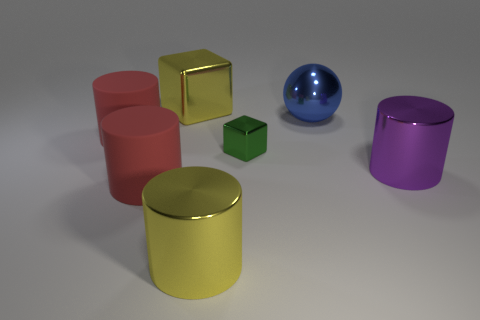There is a shiny cylinder that is left of the big purple cylinder that is in front of the big blue thing; what color is it?
Give a very brief answer. Yellow. There is a object that is to the right of the big blue metallic thing; is it the same shape as the red matte thing in front of the tiny metal thing?
Your answer should be very brief. Yes. What is the shape of the purple metallic object that is the same size as the blue metal ball?
Keep it short and to the point. Cylinder. What is the color of the small object that is the same material as the large yellow cylinder?
Give a very brief answer. Green. There is a blue shiny object; does it have the same shape as the big red object that is behind the small metallic object?
Your answer should be very brief. No. There is a large object that is the same color as the big metal block; what is its material?
Ensure brevity in your answer.  Metal. What is the material of the yellow cube that is the same size as the purple metal cylinder?
Offer a very short reply. Metal. The big thing that is both to the right of the big yellow metal cube and to the left of the large shiny ball has what shape?
Provide a short and direct response. Cylinder. Are there fewer large red objects right of the green thing than yellow metal cylinders right of the sphere?
Ensure brevity in your answer.  No. There is a big red object that is in front of the large metallic cylinder that is on the right side of the large metal cylinder left of the blue ball; what is it made of?
Provide a succinct answer. Rubber. 